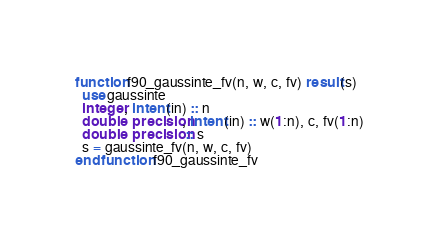<code> <loc_0><loc_0><loc_500><loc_500><_FORTRAN_>function f90_gaussinte_fv(n, w, c, fv) result(s)
  use gaussinte
  integer, intent(in) :: n
  double precision, intent(in) :: w(1:n), c, fv(1:n)
  double precision :: s
  s = gaussinte_fv(n, w, c, fv)
end function f90_gaussinte_fv
</code> 